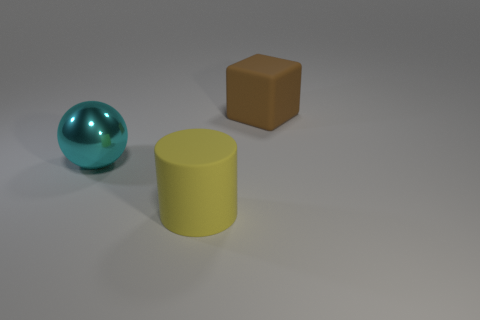Add 2 large gray metal balls. How many objects exist? 5 Subtract all cyan metal balls. Subtract all cyan rubber cylinders. How many objects are left? 2 Add 3 cyan things. How many cyan things are left? 4 Add 1 green metal cylinders. How many green metal cylinders exist? 1 Subtract 0 cyan cylinders. How many objects are left? 3 Subtract all cylinders. How many objects are left? 2 Subtract 1 cubes. How many cubes are left? 0 Subtract all brown cylinders. Subtract all green balls. How many cylinders are left? 1 